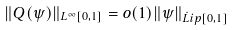<formula> <loc_0><loc_0><loc_500><loc_500>\| Q ( \psi ) \| _ { L ^ { \infty } [ 0 , 1 ] } = o ( 1 ) \| \psi \| _ { \dot { L } i p [ 0 , 1 ] }</formula> 